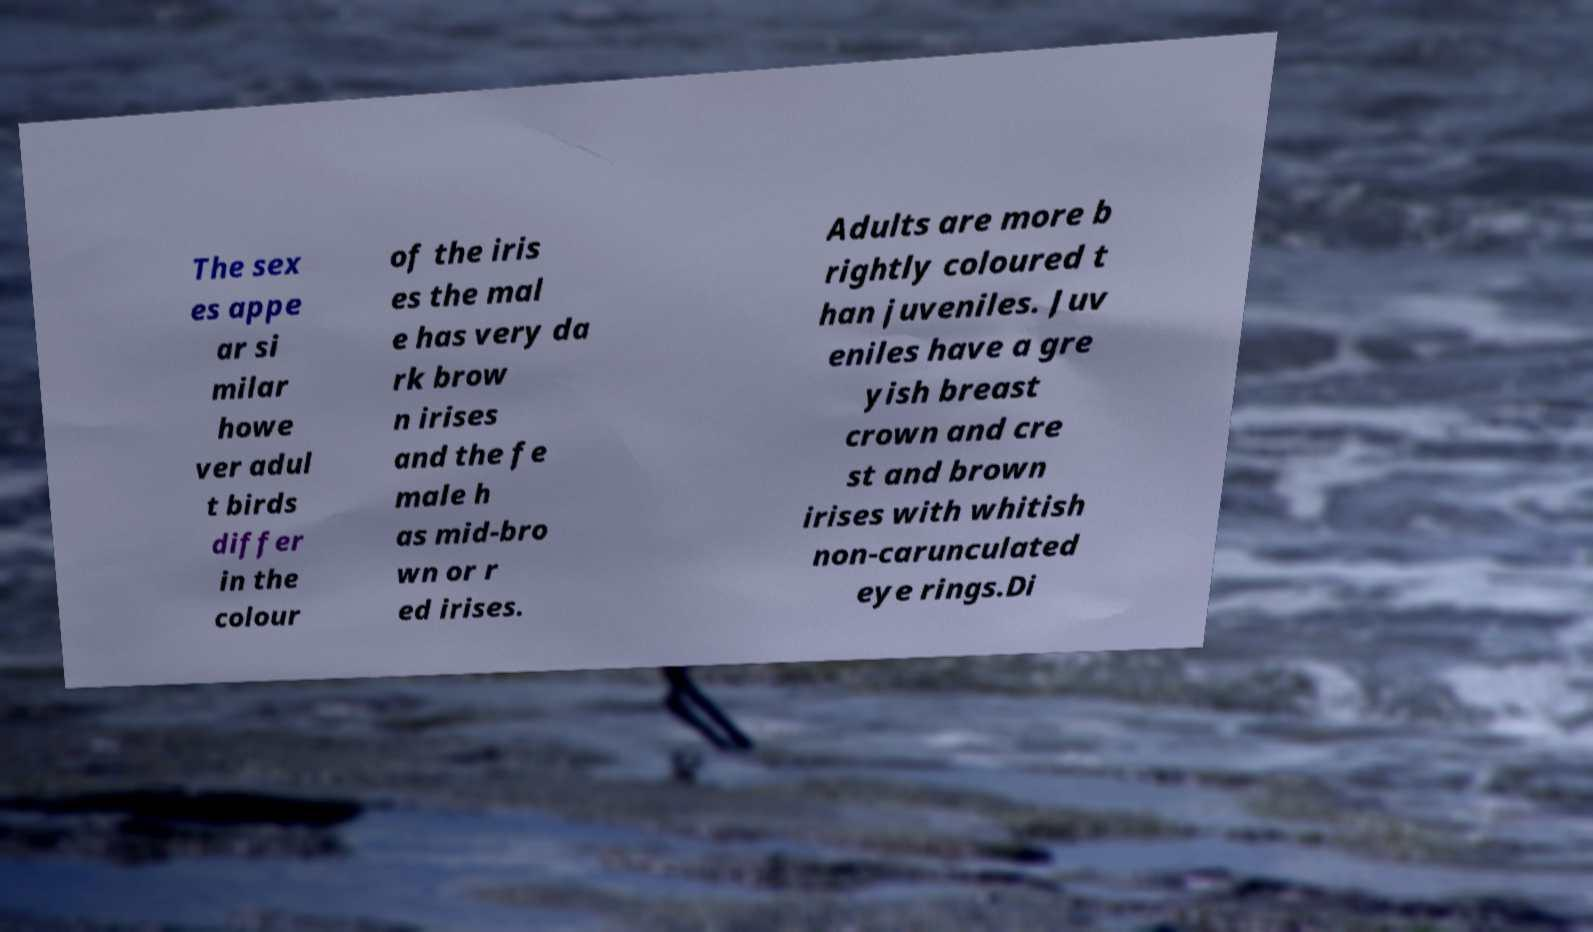Could you extract and type out the text from this image? The sex es appe ar si milar howe ver adul t birds differ in the colour of the iris es the mal e has very da rk brow n irises and the fe male h as mid-bro wn or r ed irises. Adults are more b rightly coloured t han juveniles. Juv eniles have a gre yish breast crown and cre st and brown irises with whitish non-carunculated eye rings.Di 